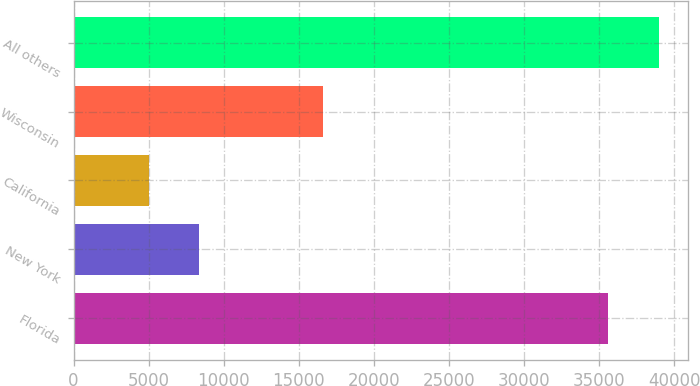Convert chart. <chart><loc_0><loc_0><loc_500><loc_500><bar_chart><fcel>Florida<fcel>New York<fcel>California<fcel>Wisconsin<fcel>All others<nl><fcel>35591<fcel>8378.2<fcel>4999<fcel>16641<fcel>38970.2<nl></chart> 